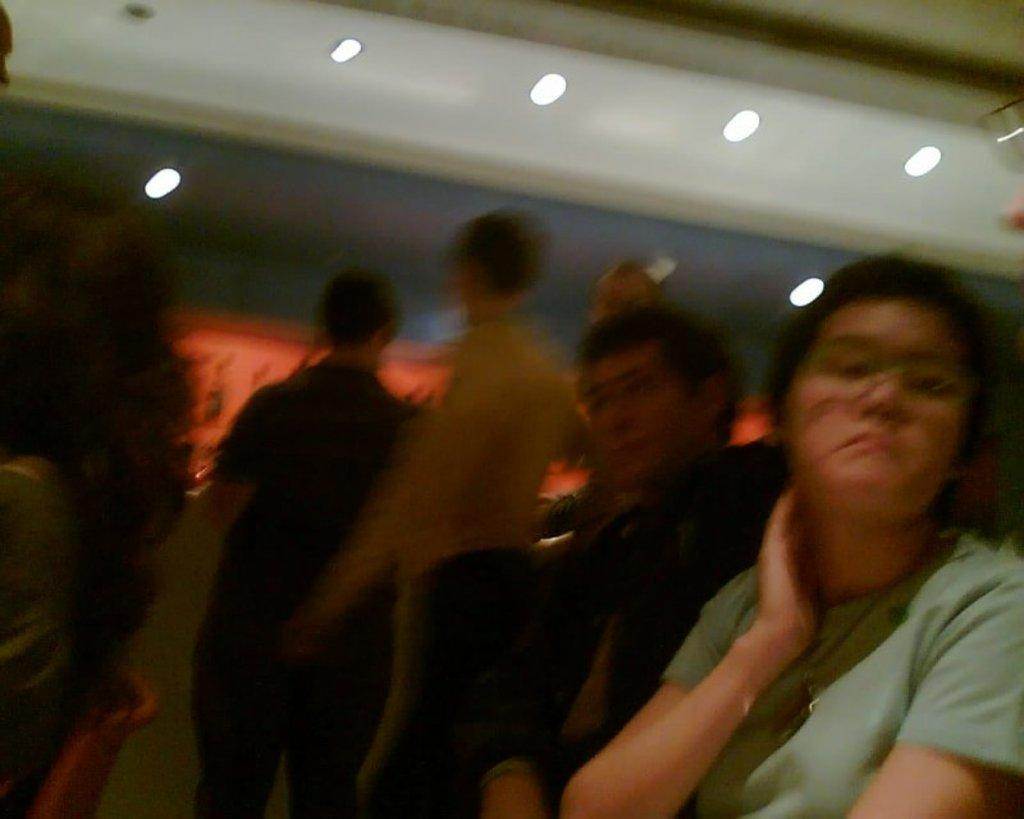Who or what can be seen in the image? There are people in the image. What else is present in the image besides the people? There are lights in the image. What type of wood is being used to build the addition in the image? There is no addition or wood present in the image; it only features people and lights. 